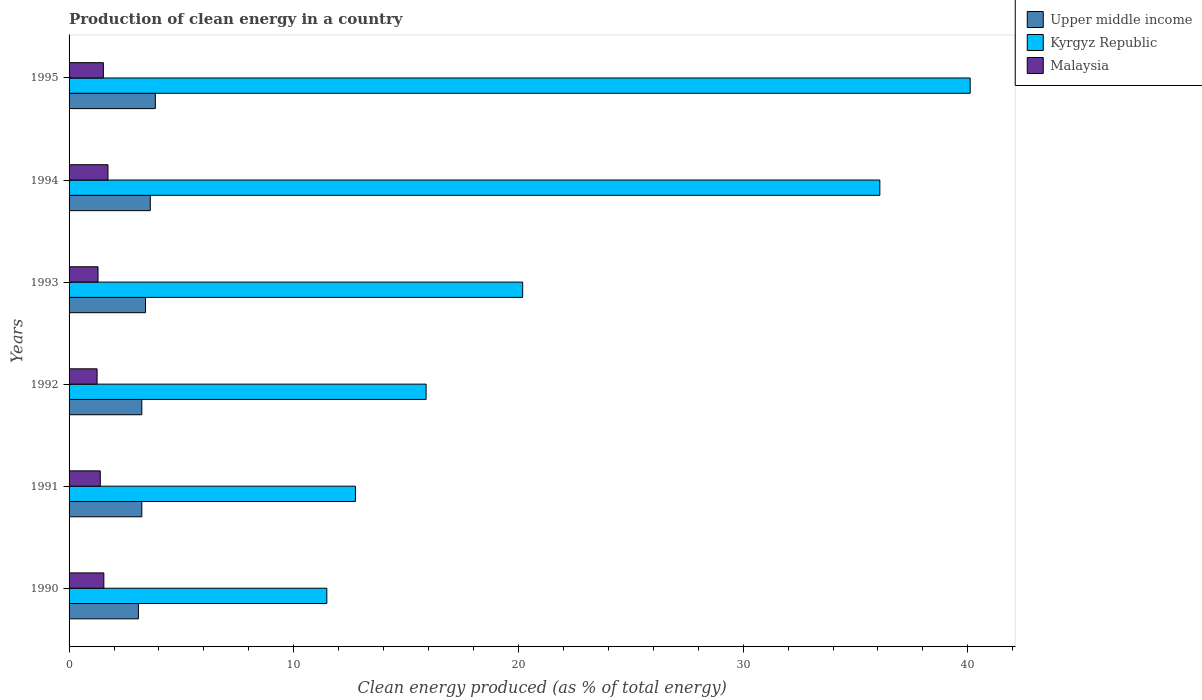How many different coloured bars are there?
Keep it short and to the point. 3. What is the percentage of clean energy produced in Kyrgyz Republic in 1993?
Your answer should be very brief. 20.19. Across all years, what is the maximum percentage of clean energy produced in Malaysia?
Provide a short and direct response. 1.73. Across all years, what is the minimum percentage of clean energy produced in Kyrgyz Republic?
Ensure brevity in your answer.  11.47. What is the total percentage of clean energy produced in Upper middle income in the graph?
Your response must be concise. 20.42. What is the difference between the percentage of clean energy produced in Upper middle income in 1991 and that in 1992?
Provide a succinct answer. 0. What is the difference between the percentage of clean energy produced in Malaysia in 1990 and the percentage of clean energy produced in Kyrgyz Republic in 1993?
Offer a very short reply. -18.64. What is the average percentage of clean energy produced in Upper middle income per year?
Give a very brief answer. 3.4. In the year 1991, what is the difference between the percentage of clean energy produced in Malaysia and percentage of clean energy produced in Kyrgyz Republic?
Your response must be concise. -11.35. In how many years, is the percentage of clean energy produced in Kyrgyz Republic greater than 4 %?
Provide a short and direct response. 6. What is the ratio of the percentage of clean energy produced in Malaysia in 1993 to that in 1995?
Make the answer very short. 0.84. Is the difference between the percentage of clean energy produced in Malaysia in 1990 and 1992 greater than the difference between the percentage of clean energy produced in Kyrgyz Republic in 1990 and 1992?
Provide a short and direct response. Yes. What is the difference between the highest and the second highest percentage of clean energy produced in Upper middle income?
Offer a terse response. 0.23. What is the difference between the highest and the lowest percentage of clean energy produced in Upper middle income?
Give a very brief answer. 0.75. In how many years, is the percentage of clean energy produced in Upper middle income greater than the average percentage of clean energy produced in Upper middle income taken over all years?
Give a very brief answer. 2. What does the 3rd bar from the top in 1992 represents?
Your answer should be compact. Upper middle income. What does the 3rd bar from the bottom in 1990 represents?
Offer a terse response. Malaysia. How many bars are there?
Ensure brevity in your answer.  18. Are all the bars in the graph horizontal?
Ensure brevity in your answer.  Yes. Where does the legend appear in the graph?
Provide a succinct answer. Top right. How are the legend labels stacked?
Your answer should be compact. Vertical. What is the title of the graph?
Ensure brevity in your answer.  Production of clean energy in a country. What is the label or title of the X-axis?
Your answer should be compact. Clean energy produced (as % of total energy). What is the Clean energy produced (as % of total energy) of Upper middle income in 1990?
Provide a short and direct response. 3.09. What is the Clean energy produced (as % of total energy) in Kyrgyz Republic in 1990?
Give a very brief answer. 11.47. What is the Clean energy produced (as % of total energy) of Malaysia in 1990?
Your answer should be very brief. 1.55. What is the Clean energy produced (as % of total energy) of Upper middle income in 1991?
Provide a short and direct response. 3.24. What is the Clean energy produced (as % of total energy) in Kyrgyz Republic in 1991?
Your answer should be very brief. 12.74. What is the Clean energy produced (as % of total energy) in Malaysia in 1991?
Your response must be concise. 1.39. What is the Clean energy produced (as % of total energy) of Upper middle income in 1992?
Offer a very short reply. 3.24. What is the Clean energy produced (as % of total energy) in Kyrgyz Republic in 1992?
Offer a terse response. 15.89. What is the Clean energy produced (as % of total energy) of Malaysia in 1992?
Provide a succinct answer. 1.25. What is the Clean energy produced (as % of total energy) in Upper middle income in 1993?
Offer a terse response. 3.4. What is the Clean energy produced (as % of total energy) in Kyrgyz Republic in 1993?
Provide a short and direct response. 20.19. What is the Clean energy produced (as % of total energy) of Malaysia in 1993?
Your answer should be very brief. 1.29. What is the Clean energy produced (as % of total energy) in Upper middle income in 1994?
Offer a very short reply. 3.61. What is the Clean energy produced (as % of total energy) of Kyrgyz Republic in 1994?
Offer a very short reply. 36.08. What is the Clean energy produced (as % of total energy) of Malaysia in 1994?
Your answer should be compact. 1.73. What is the Clean energy produced (as % of total energy) in Upper middle income in 1995?
Provide a short and direct response. 3.84. What is the Clean energy produced (as % of total energy) in Kyrgyz Republic in 1995?
Provide a succinct answer. 40.1. What is the Clean energy produced (as % of total energy) of Malaysia in 1995?
Your answer should be compact. 1.53. Across all years, what is the maximum Clean energy produced (as % of total energy) of Upper middle income?
Provide a short and direct response. 3.84. Across all years, what is the maximum Clean energy produced (as % of total energy) of Kyrgyz Republic?
Offer a very short reply. 40.1. Across all years, what is the maximum Clean energy produced (as % of total energy) of Malaysia?
Offer a very short reply. 1.73. Across all years, what is the minimum Clean energy produced (as % of total energy) in Upper middle income?
Offer a very short reply. 3.09. Across all years, what is the minimum Clean energy produced (as % of total energy) of Kyrgyz Republic?
Make the answer very short. 11.47. Across all years, what is the minimum Clean energy produced (as % of total energy) in Malaysia?
Your response must be concise. 1.25. What is the total Clean energy produced (as % of total energy) in Upper middle income in the graph?
Ensure brevity in your answer.  20.42. What is the total Clean energy produced (as % of total energy) of Kyrgyz Republic in the graph?
Keep it short and to the point. 136.48. What is the total Clean energy produced (as % of total energy) in Malaysia in the graph?
Your answer should be very brief. 8.73. What is the difference between the Clean energy produced (as % of total energy) of Upper middle income in 1990 and that in 1991?
Make the answer very short. -0.15. What is the difference between the Clean energy produced (as % of total energy) of Kyrgyz Republic in 1990 and that in 1991?
Make the answer very short. -1.27. What is the difference between the Clean energy produced (as % of total energy) of Malaysia in 1990 and that in 1991?
Your answer should be very brief. 0.16. What is the difference between the Clean energy produced (as % of total energy) in Upper middle income in 1990 and that in 1992?
Your answer should be compact. -0.15. What is the difference between the Clean energy produced (as % of total energy) in Kyrgyz Republic in 1990 and that in 1992?
Keep it short and to the point. -4.42. What is the difference between the Clean energy produced (as % of total energy) of Malaysia in 1990 and that in 1992?
Make the answer very short. 0.3. What is the difference between the Clean energy produced (as % of total energy) in Upper middle income in 1990 and that in 1993?
Make the answer very short. -0.32. What is the difference between the Clean energy produced (as % of total energy) of Kyrgyz Republic in 1990 and that in 1993?
Make the answer very short. -8.72. What is the difference between the Clean energy produced (as % of total energy) of Malaysia in 1990 and that in 1993?
Keep it short and to the point. 0.26. What is the difference between the Clean energy produced (as % of total energy) of Upper middle income in 1990 and that in 1994?
Offer a very short reply. -0.53. What is the difference between the Clean energy produced (as % of total energy) of Kyrgyz Republic in 1990 and that in 1994?
Offer a very short reply. -24.61. What is the difference between the Clean energy produced (as % of total energy) of Malaysia in 1990 and that in 1994?
Provide a succinct answer. -0.18. What is the difference between the Clean energy produced (as % of total energy) of Upper middle income in 1990 and that in 1995?
Provide a succinct answer. -0.75. What is the difference between the Clean energy produced (as % of total energy) of Kyrgyz Republic in 1990 and that in 1995?
Offer a terse response. -28.63. What is the difference between the Clean energy produced (as % of total energy) of Malaysia in 1990 and that in 1995?
Your answer should be very brief. 0.02. What is the difference between the Clean energy produced (as % of total energy) of Upper middle income in 1991 and that in 1992?
Ensure brevity in your answer.  0. What is the difference between the Clean energy produced (as % of total energy) in Kyrgyz Republic in 1991 and that in 1992?
Ensure brevity in your answer.  -3.15. What is the difference between the Clean energy produced (as % of total energy) in Malaysia in 1991 and that in 1992?
Offer a very short reply. 0.14. What is the difference between the Clean energy produced (as % of total energy) in Upper middle income in 1991 and that in 1993?
Provide a succinct answer. -0.16. What is the difference between the Clean energy produced (as % of total energy) of Kyrgyz Republic in 1991 and that in 1993?
Keep it short and to the point. -7.44. What is the difference between the Clean energy produced (as % of total energy) in Malaysia in 1991 and that in 1993?
Offer a very short reply. 0.1. What is the difference between the Clean energy produced (as % of total energy) in Upper middle income in 1991 and that in 1994?
Your answer should be compact. -0.38. What is the difference between the Clean energy produced (as % of total energy) in Kyrgyz Republic in 1991 and that in 1994?
Your answer should be compact. -23.34. What is the difference between the Clean energy produced (as % of total energy) in Malaysia in 1991 and that in 1994?
Your answer should be compact. -0.34. What is the difference between the Clean energy produced (as % of total energy) in Upper middle income in 1991 and that in 1995?
Make the answer very short. -0.6. What is the difference between the Clean energy produced (as % of total energy) of Kyrgyz Republic in 1991 and that in 1995?
Ensure brevity in your answer.  -27.36. What is the difference between the Clean energy produced (as % of total energy) in Malaysia in 1991 and that in 1995?
Offer a terse response. -0.14. What is the difference between the Clean energy produced (as % of total energy) of Upper middle income in 1992 and that in 1993?
Give a very brief answer. -0.17. What is the difference between the Clean energy produced (as % of total energy) of Kyrgyz Republic in 1992 and that in 1993?
Offer a terse response. -4.3. What is the difference between the Clean energy produced (as % of total energy) in Malaysia in 1992 and that in 1993?
Offer a very short reply. -0.04. What is the difference between the Clean energy produced (as % of total energy) in Upper middle income in 1992 and that in 1994?
Provide a short and direct response. -0.38. What is the difference between the Clean energy produced (as % of total energy) of Kyrgyz Republic in 1992 and that in 1994?
Keep it short and to the point. -20.19. What is the difference between the Clean energy produced (as % of total energy) in Malaysia in 1992 and that in 1994?
Your response must be concise. -0.48. What is the difference between the Clean energy produced (as % of total energy) of Upper middle income in 1992 and that in 1995?
Your answer should be compact. -0.6. What is the difference between the Clean energy produced (as % of total energy) in Kyrgyz Republic in 1992 and that in 1995?
Your response must be concise. -24.21. What is the difference between the Clean energy produced (as % of total energy) in Malaysia in 1992 and that in 1995?
Keep it short and to the point. -0.28. What is the difference between the Clean energy produced (as % of total energy) in Upper middle income in 1993 and that in 1994?
Your answer should be very brief. -0.21. What is the difference between the Clean energy produced (as % of total energy) of Kyrgyz Republic in 1993 and that in 1994?
Your response must be concise. -15.9. What is the difference between the Clean energy produced (as % of total energy) of Malaysia in 1993 and that in 1994?
Ensure brevity in your answer.  -0.44. What is the difference between the Clean energy produced (as % of total energy) of Upper middle income in 1993 and that in 1995?
Your answer should be compact. -0.44. What is the difference between the Clean energy produced (as % of total energy) in Kyrgyz Republic in 1993 and that in 1995?
Provide a succinct answer. -19.92. What is the difference between the Clean energy produced (as % of total energy) of Malaysia in 1993 and that in 1995?
Your answer should be very brief. -0.24. What is the difference between the Clean energy produced (as % of total energy) in Upper middle income in 1994 and that in 1995?
Make the answer very short. -0.23. What is the difference between the Clean energy produced (as % of total energy) of Kyrgyz Republic in 1994 and that in 1995?
Offer a very short reply. -4.02. What is the difference between the Clean energy produced (as % of total energy) in Malaysia in 1994 and that in 1995?
Make the answer very short. 0.2. What is the difference between the Clean energy produced (as % of total energy) of Upper middle income in 1990 and the Clean energy produced (as % of total energy) of Kyrgyz Republic in 1991?
Keep it short and to the point. -9.66. What is the difference between the Clean energy produced (as % of total energy) of Upper middle income in 1990 and the Clean energy produced (as % of total energy) of Malaysia in 1991?
Your answer should be very brief. 1.7. What is the difference between the Clean energy produced (as % of total energy) in Kyrgyz Republic in 1990 and the Clean energy produced (as % of total energy) in Malaysia in 1991?
Your answer should be compact. 10.08. What is the difference between the Clean energy produced (as % of total energy) of Upper middle income in 1990 and the Clean energy produced (as % of total energy) of Kyrgyz Republic in 1992?
Your response must be concise. -12.8. What is the difference between the Clean energy produced (as % of total energy) of Upper middle income in 1990 and the Clean energy produced (as % of total energy) of Malaysia in 1992?
Your response must be concise. 1.84. What is the difference between the Clean energy produced (as % of total energy) of Kyrgyz Republic in 1990 and the Clean energy produced (as % of total energy) of Malaysia in 1992?
Offer a very short reply. 10.23. What is the difference between the Clean energy produced (as % of total energy) of Upper middle income in 1990 and the Clean energy produced (as % of total energy) of Kyrgyz Republic in 1993?
Make the answer very short. -17.1. What is the difference between the Clean energy produced (as % of total energy) of Upper middle income in 1990 and the Clean energy produced (as % of total energy) of Malaysia in 1993?
Your response must be concise. 1.8. What is the difference between the Clean energy produced (as % of total energy) of Kyrgyz Republic in 1990 and the Clean energy produced (as % of total energy) of Malaysia in 1993?
Offer a terse response. 10.18. What is the difference between the Clean energy produced (as % of total energy) in Upper middle income in 1990 and the Clean energy produced (as % of total energy) in Kyrgyz Republic in 1994?
Your answer should be compact. -33. What is the difference between the Clean energy produced (as % of total energy) of Upper middle income in 1990 and the Clean energy produced (as % of total energy) of Malaysia in 1994?
Offer a very short reply. 1.35. What is the difference between the Clean energy produced (as % of total energy) in Kyrgyz Republic in 1990 and the Clean energy produced (as % of total energy) in Malaysia in 1994?
Your answer should be very brief. 9.74. What is the difference between the Clean energy produced (as % of total energy) in Upper middle income in 1990 and the Clean energy produced (as % of total energy) in Kyrgyz Republic in 1995?
Ensure brevity in your answer.  -37.02. What is the difference between the Clean energy produced (as % of total energy) of Upper middle income in 1990 and the Clean energy produced (as % of total energy) of Malaysia in 1995?
Offer a terse response. 1.56. What is the difference between the Clean energy produced (as % of total energy) in Kyrgyz Republic in 1990 and the Clean energy produced (as % of total energy) in Malaysia in 1995?
Make the answer very short. 9.94. What is the difference between the Clean energy produced (as % of total energy) of Upper middle income in 1991 and the Clean energy produced (as % of total energy) of Kyrgyz Republic in 1992?
Your answer should be very brief. -12.65. What is the difference between the Clean energy produced (as % of total energy) in Upper middle income in 1991 and the Clean energy produced (as % of total energy) in Malaysia in 1992?
Your answer should be compact. 1.99. What is the difference between the Clean energy produced (as % of total energy) of Kyrgyz Republic in 1991 and the Clean energy produced (as % of total energy) of Malaysia in 1992?
Offer a terse response. 11.5. What is the difference between the Clean energy produced (as % of total energy) in Upper middle income in 1991 and the Clean energy produced (as % of total energy) in Kyrgyz Republic in 1993?
Give a very brief answer. -16.95. What is the difference between the Clean energy produced (as % of total energy) of Upper middle income in 1991 and the Clean energy produced (as % of total energy) of Malaysia in 1993?
Give a very brief answer. 1.95. What is the difference between the Clean energy produced (as % of total energy) of Kyrgyz Republic in 1991 and the Clean energy produced (as % of total energy) of Malaysia in 1993?
Keep it short and to the point. 11.46. What is the difference between the Clean energy produced (as % of total energy) of Upper middle income in 1991 and the Clean energy produced (as % of total energy) of Kyrgyz Republic in 1994?
Ensure brevity in your answer.  -32.85. What is the difference between the Clean energy produced (as % of total energy) of Upper middle income in 1991 and the Clean energy produced (as % of total energy) of Malaysia in 1994?
Your answer should be very brief. 1.51. What is the difference between the Clean energy produced (as % of total energy) in Kyrgyz Republic in 1991 and the Clean energy produced (as % of total energy) in Malaysia in 1994?
Make the answer very short. 11.01. What is the difference between the Clean energy produced (as % of total energy) of Upper middle income in 1991 and the Clean energy produced (as % of total energy) of Kyrgyz Republic in 1995?
Your answer should be very brief. -36.87. What is the difference between the Clean energy produced (as % of total energy) in Upper middle income in 1991 and the Clean energy produced (as % of total energy) in Malaysia in 1995?
Provide a short and direct response. 1.71. What is the difference between the Clean energy produced (as % of total energy) in Kyrgyz Republic in 1991 and the Clean energy produced (as % of total energy) in Malaysia in 1995?
Make the answer very short. 11.22. What is the difference between the Clean energy produced (as % of total energy) in Upper middle income in 1992 and the Clean energy produced (as % of total energy) in Kyrgyz Republic in 1993?
Provide a short and direct response. -16.95. What is the difference between the Clean energy produced (as % of total energy) of Upper middle income in 1992 and the Clean energy produced (as % of total energy) of Malaysia in 1993?
Provide a short and direct response. 1.95. What is the difference between the Clean energy produced (as % of total energy) of Kyrgyz Republic in 1992 and the Clean energy produced (as % of total energy) of Malaysia in 1993?
Provide a succinct answer. 14.6. What is the difference between the Clean energy produced (as % of total energy) in Upper middle income in 1992 and the Clean energy produced (as % of total energy) in Kyrgyz Republic in 1994?
Ensure brevity in your answer.  -32.85. What is the difference between the Clean energy produced (as % of total energy) in Upper middle income in 1992 and the Clean energy produced (as % of total energy) in Malaysia in 1994?
Your response must be concise. 1.51. What is the difference between the Clean energy produced (as % of total energy) of Kyrgyz Republic in 1992 and the Clean energy produced (as % of total energy) of Malaysia in 1994?
Keep it short and to the point. 14.16. What is the difference between the Clean energy produced (as % of total energy) of Upper middle income in 1992 and the Clean energy produced (as % of total energy) of Kyrgyz Republic in 1995?
Ensure brevity in your answer.  -36.87. What is the difference between the Clean energy produced (as % of total energy) of Upper middle income in 1992 and the Clean energy produced (as % of total energy) of Malaysia in 1995?
Ensure brevity in your answer.  1.71. What is the difference between the Clean energy produced (as % of total energy) of Kyrgyz Republic in 1992 and the Clean energy produced (as % of total energy) of Malaysia in 1995?
Ensure brevity in your answer.  14.36. What is the difference between the Clean energy produced (as % of total energy) of Upper middle income in 1993 and the Clean energy produced (as % of total energy) of Kyrgyz Republic in 1994?
Keep it short and to the point. -32.68. What is the difference between the Clean energy produced (as % of total energy) of Upper middle income in 1993 and the Clean energy produced (as % of total energy) of Malaysia in 1994?
Your response must be concise. 1.67. What is the difference between the Clean energy produced (as % of total energy) of Kyrgyz Republic in 1993 and the Clean energy produced (as % of total energy) of Malaysia in 1994?
Make the answer very short. 18.46. What is the difference between the Clean energy produced (as % of total energy) of Upper middle income in 1993 and the Clean energy produced (as % of total energy) of Kyrgyz Republic in 1995?
Provide a short and direct response. -36.7. What is the difference between the Clean energy produced (as % of total energy) of Upper middle income in 1993 and the Clean energy produced (as % of total energy) of Malaysia in 1995?
Your answer should be very brief. 1.88. What is the difference between the Clean energy produced (as % of total energy) of Kyrgyz Republic in 1993 and the Clean energy produced (as % of total energy) of Malaysia in 1995?
Ensure brevity in your answer.  18.66. What is the difference between the Clean energy produced (as % of total energy) in Upper middle income in 1994 and the Clean energy produced (as % of total energy) in Kyrgyz Republic in 1995?
Offer a terse response. -36.49. What is the difference between the Clean energy produced (as % of total energy) in Upper middle income in 1994 and the Clean energy produced (as % of total energy) in Malaysia in 1995?
Ensure brevity in your answer.  2.09. What is the difference between the Clean energy produced (as % of total energy) in Kyrgyz Republic in 1994 and the Clean energy produced (as % of total energy) in Malaysia in 1995?
Your response must be concise. 34.56. What is the average Clean energy produced (as % of total energy) in Upper middle income per year?
Make the answer very short. 3.4. What is the average Clean energy produced (as % of total energy) of Kyrgyz Republic per year?
Your response must be concise. 22.75. What is the average Clean energy produced (as % of total energy) in Malaysia per year?
Provide a succinct answer. 1.46. In the year 1990, what is the difference between the Clean energy produced (as % of total energy) in Upper middle income and Clean energy produced (as % of total energy) in Kyrgyz Republic?
Give a very brief answer. -8.39. In the year 1990, what is the difference between the Clean energy produced (as % of total energy) in Upper middle income and Clean energy produced (as % of total energy) in Malaysia?
Offer a terse response. 1.54. In the year 1990, what is the difference between the Clean energy produced (as % of total energy) in Kyrgyz Republic and Clean energy produced (as % of total energy) in Malaysia?
Provide a succinct answer. 9.92. In the year 1991, what is the difference between the Clean energy produced (as % of total energy) in Upper middle income and Clean energy produced (as % of total energy) in Kyrgyz Republic?
Your response must be concise. -9.51. In the year 1991, what is the difference between the Clean energy produced (as % of total energy) of Upper middle income and Clean energy produced (as % of total energy) of Malaysia?
Provide a succinct answer. 1.85. In the year 1991, what is the difference between the Clean energy produced (as % of total energy) in Kyrgyz Republic and Clean energy produced (as % of total energy) in Malaysia?
Your answer should be compact. 11.35. In the year 1992, what is the difference between the Clean energy produced (as % of total energy) in Upper middle income and Clean energy produced (as % of total energy) in Kyrgyz Republic?
Keep it short and to the point. -12.65. In the year 1992, what is the difference between the Clean energy produced (as % of total energy) of Upper middle income and Clean energy produced (as % of total energy) of Malaysia?
Keep it short and to the point. 1.99. In the year 1992, what is the difference between the Clean energy produced (as % of total energy) in Kyrgyz Republic and Clean energy produced (as % of total energy) in Malaysia?
Your answer should be compact. 14.64. In the year 1993, what is the difference between the Clean energy produced (as % of total energy) of Upper middle income and Clean energy produced (as % of total energy) of Kyrgyz Republic?
Your answer should be very brief. -16.79. In the year 1993, what is the difference between the Clean energy produced (as % of total energy) in Upper middle income and Clean energy produced (as % of total energy) in Malaysia?
Your answer should be compact. 2.11. In the year 1993, what is the difference between the Clean energy produced (as % of total energy) of Kyrgyz Republic and Clean energy produced (as % of total energy) of Malaysia?
Keep it short and to the point. 18.9. In the year 1994, what is the difference between the Clean energy produced (as % of total energy) in Upper middle income and Clean energy produced (as % of total energy) in Kyrgyz Republic?
Offer a terse response. -32.47. In the year 1994, what is the difference between the Clean energy produced (as % of total energy) of Upper middle income and Clean energy produced (as % of total energy) of Malaysia?
Provide a succinct answer. 1.88. In the year 1994, what is the difference between the Clean energy produced (as % of total energy) in Kyrgyz Republic and Clean energy produced (as % of total energy) in Malaysia?
Give a very brief answer. 34.35. In the year 1995, what is the difference between the Clean energy produced (as % of total energy) of Upper middle income and Clean energy produced (as % of total energy) of Kyrgyz Republic?
Your answer should be very brief. -36.26. In the year 1995, what is the difference between the Clean energy produced (as % of total energy) in Upper middle income and Clean energy produced (as % of total energy) in Malaysia?
Ensure brevity in your answer.  2.31. In the year 1995, what is the difference between the Clean energy produced (as % of total energy) in Kyrgyz Republic and Clean energy produced (as % of total energy) in Malaysia?
Provide a short and direct response. 38.58. What is the ratio of the Clean energy produced (as % of total energy) in Upper middle income in 1990 to that in 1991?
Your answer should be compact. 0.95. What is the ratio of the Clean energy produced (as % of total energy) of Kyrgyz Republic in 1990 to that in 1991?
Offer a terse response. 0.9. What is the ratio of the Clean energy produced (as % of total energy) in Malaysia in 1990 to that in 1991?
Keep it short and to the point. 1.11. What is the ratio of the Clean energy produced (as % of total energy) of Upper middle income in 1990 to that in 1992?
Your answer should be compact. 0.95. What is the ratio of the Clean energy produced (as % of total energy) of Kyrgyz Republic in 1990 to that in 1992?
Provide a succinct answer. 0.72. What is the ratio of the Clean energy produced (as % of total energy) of Malaysia in 1990 to that in 1992?
Ensure brevity in your answer.  1.24. What is the ratio of the Clean energy produced (as % of total energy) of Upper middle income in 1990 to that in 1993?
Offer a terse response. 0.91. What is the ratio of the Clean energy produced (as % of total energy) of Kyrgyz Republic in 1990 to that in 1993?
Your answer should be very brief. 0.57. What is the ratio of the Clean energy produced (as % of total energy) in Malaysia in 1990 to that in 1993?
Offer a terse response. 1.2. What is the ratio of the Clean energy produced (as % of total energy) in Upper middle income in 1990 to that in 1994?
Offer a very short reply. 0.85. What is the ratio of the Clean energy produced (as % of total energy) of Kyrgyz Republic in 1990 to that in 1994?
Offer a terse response. 0.32. What is the ratio of the Clean energy produced (as % of total energy) of Malaysia in 1990 to that in 1994?
Provide a succinct answer. 0.89. What is the ratio of the Clean energy produced (as % of total energy) in Upper middle income in 1990 to that in 1995?
Keep it short and to the point. 0.8. What is the ratio of the Clean energy produced (as % of total energy) in Kyrgyz Republic in 1990 to that in 1995?
Keep it short and to the point. 0.29. What is the ratio of the Clean energy produced (as % of total energy) of Malaysia in 1990 to that in 1995?
Ensure brevity in your answer.  1.01. What is the ratio of the Clean energy produced (as % of total energy) in Kyrgyz Republic in 1991 to that in 1992?
Provide a short and direct response. 0.8. What is the ratio of the Clean energy produced (as % of total energy) of Malaysia in 1991 to that in 1992?
Offer a very short reply. 1.11. What is the ratio of the Clean energy produced (as % of total energy) of Upper middle income in 1991 to that in 1993?
Ensure brevity in your answer.  0.95. What is the ratio of the Clean energy produced (as % of total energy) in Kyrgyz Republic in 1991 to that in 1993?
Your response must be concise. 0.63. What is the ratio of the Clean energy produced (as % of total energy) in Malaysia in 1991 to that in 1993?
Offer a very short reply. 1.08. What is the ratio of the Clean energy produced (as % of total energy) of Upper middle income in 1991 to that in 1994?
Keep it short and to the point. 0.9. What is the ratio of the Clean energy produced (as % of total energy) in Kyrgyz Republic in 1991 to that in 1994?
Offer a very short reply. 0.35. What is the ratio of the Clean energy produced (as % of total energy) of Malaysia in 1991 to that in 1994?
Your response must be concise. 0.8. What is the ratio of the Clean energy produced (as % of total energy) in Upper middle income in 1991 to that in 1995?
Offer a terse response. 0.84. What is the ratio of the Clean energy produced (as % of total energy) in Kyrgyz Republic in 1991 to that in 1995?
Give a very brief answer. 0.32. What is the ratio of the Clean energy produced (as % of total energy) of Malaysia in 1991 to that in 1995?
Offer a terse response. 0.91. What is the ratio of the Clean energy produced (as % of total energy) in Upper middle income in 1992 to that in 1993?
Keep it short and to the point. 0.95. What is the ratio of the Clean energy produced (as % of total energy) in Kyrgyz Republic in 1992 to that in 1993?
Give a very brief answer. 0.79. What is the ratio of the Clean energy produced (as % of total energy) in Malaysia in 1992 to that in 1993?
Provide a short and direct response. 0.97. What is the ratio of the Clean energy produced (as % of total energy) of Upper middle income in 1992 to that in 1994?
Provide a short and direct response. 0.9. What is the ratio of the Clean energy produced (as % of total energy) of Kyrgyz Republic in 1992 to that in 1994?
Provide a succinct answer. 0.44. What is the ratio of the Clean energy produced (as % of total energy) in Malaysia in 1992 to that in 1994?
Provide a short and direct response. 0.72. What is the ratio of the Clean energy produced (as % of total energy) in Upper middle income in 1992 to that in 1995?
Your answer should be very brief. 0.84. What is the ratio of the Clean energy produced (as % of total energy) of Kyrgyz Republic in 1992 to that in 1995?
Keep it short and to the point. 0.4. What is the ratio of the Clean energy produced (as % of total energy) of Malaysia in 1992 to that in 1995?
Provide a short and direct response. 0.82. What is the ratio of the Clean energy produced (as % of total energy) in Upper middle income in 1993 to that in 1994?
Offer a very short reply. 0.94. What is the ratio of the Clean energy produced (as % of total energy) of Kyrgyz Republic in 1993 to that in 1994?
Your response must be concise. 0.56. What is the ratio of the Clean energy produced (as % of total energy) in Malaysia in 1993 to that in 1994?
Provide a succinct answer. 0.74. What is the ratio of the Clean energy produced (as % of total energy) of Upper middle income in 1993 to that in 1995?
Your response must be concise. 0.89. What is the ratio of the Clean energy produced (as % of total energy) in Kyrgyz Republic in 1993 to that in 1995?
Make the answer very short. 0.5. What is the ratio of the Clean energy produced (as % of total energy) in Malaysia in 1993 to that in 1995?
Keep it short and to the point. 0.84. What is the ratio of the Clean energy produced (as % of total energy) in Upper middle income in 1994 to that in 1995?
Provide a succinct answer. 0.94. What is the ratio of the Clean energy produced (as % of total energy) of Kyrgyz Republic in 1994 to that in 1995?
Keep it short and to the point. 0.9. What is the ratio of the Clean energy produced (as % of total energy) in Malaysia in 1994 to that in 1995?
Your answer should be very brief. 1.13. What is the difference between the highest and the second highest Clean energy produced (as % of total energy) in Upper middle income?
Keep it short and to the point. 0.23. What is the difference between the highest and the second highest Clean energy produced (as % of total energy) in Kyrgyz Republic?
Keep it short and to the point. 4.02. What is the difference between the highest and the second highest Clean energy produced (as % of total energy) of Malaysia?
Provide a short and direct response. 0.18. What is the difference between the highest and the lowest Clean energy produced (as % of total energy) in Upper middle income?
Offer a very short reply. 0.75. What is the difference between the highest and the lowest Clean energy produced (as % of total energy) in Kyrgyz Republic?
Ensure brevity in your answer.  28.63. What is the difference between the highest and the lowest Clean energy produced (as % of total energy) in Malaysia?
Give a very brief answer. 0.48. 